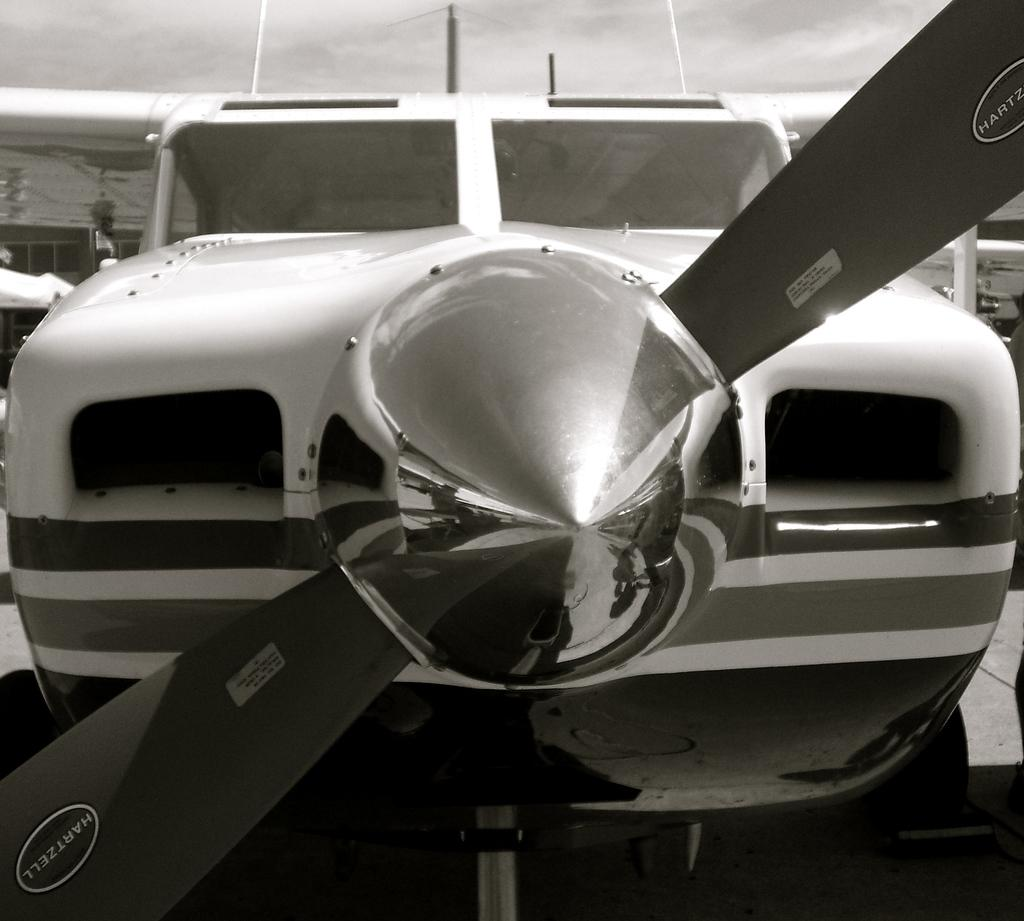What is the main subject of the image? The main subject of the image is an airplane. How is the airplane depicted in the image? The airplane is shown from a front view. What can be seen in the background of the image? The sky is visible at the top of the image. What type of quill is being used by the porter in the image? There is no porter or quill present in the image; it features an airplane from a front view with the sky visible in the background. 